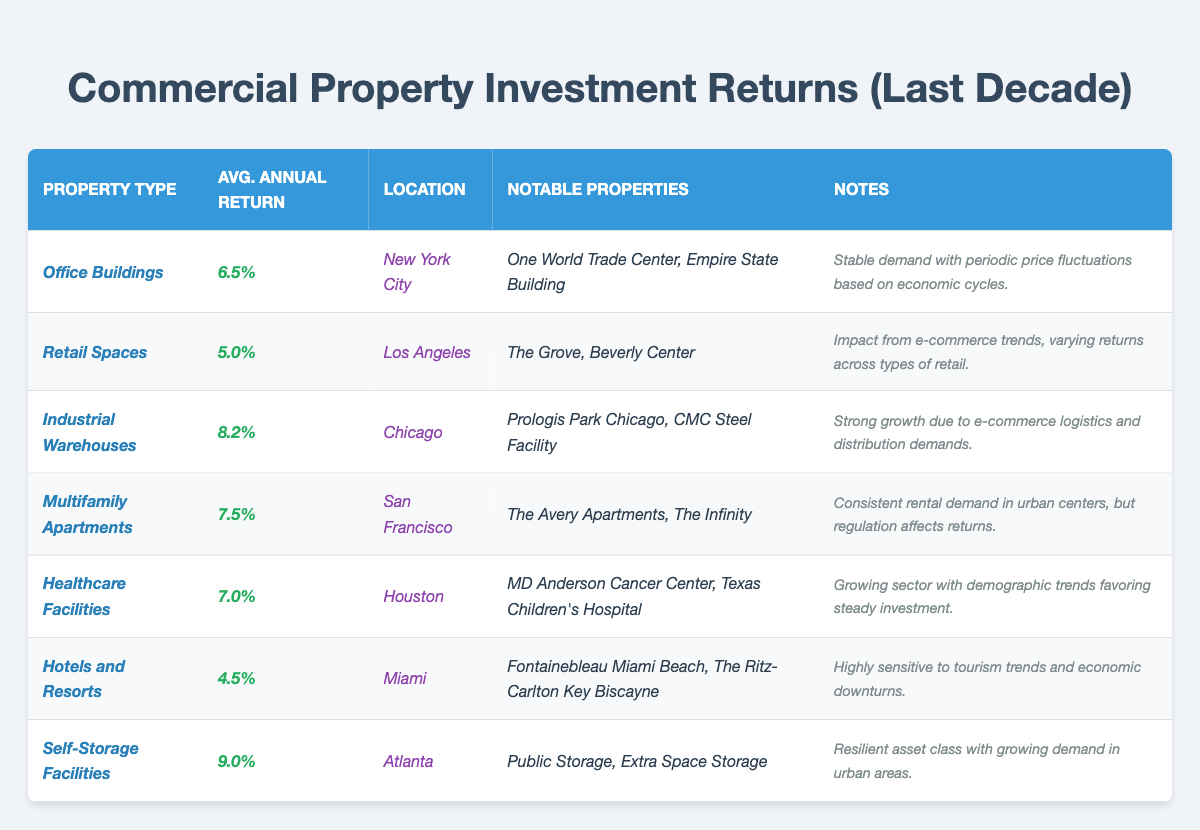What is the average annual return for Office Buildings? The table shows that the average annual return for Office Buildings is explicitly listed as 6.5%.
Answer: 6.5% Which property type has the highest average annual return? By inspecting the table, the highest average annual return is listed for Self-Storage Facilities at 9.0%.
Answer: Self-Storage Facilities Is the average annual return for Healthcare Facilities higher than that for Hotels and Resorts? The average annual return for Healthcare Facilities is 7.0%, and for Hotels and Resorts, it is 4.5%. Since 7.0% is greater than 4.5%, the statement is true.
Answer: Yes What are the notable properties for Multifamily Apartments? The notable properties for Multifamily Apartments are listed in the table as The Avery Apartments and The Infinity.
Answer: The Avery Apartments, The Infinity How does the average annual return for Retail Spaces compare to that of Industrial Warehouses? The average annual return for Retail Spaces is 5.0%, while for Industrial Warehouses, it is 8.2%. Since 5.0% is less than 8.2%, Retail Spaces have a lower return than Industrial Warehouses.
Answer: Lower What is the difference in average annual return between Industrial Warehouses and Self-Storage Facilities? The average annual return for Industrial Warehouses is 8.2% and for Self-Storage Facilities is 9.0%. To find the difference, subtract: 9.0% - 8.2% = 0.8%.
Answer: 0.8% Are all property types listed in the table located in different cities? Each property type in the table specifies a unique city for its location, which confirms that they are all different.
Answer: Yes What is the average annual return for all property types combined? First, sum the average annual returns: 6.5% + 5.0% + 8.2% + 7.5% + 7.0% + 4.5% + 9.0% = 47.7%. Then, divide by the number of property types (7) to get the average: 47.7% / 7 = 6.81%.
Answer: 6.81% Which property type has the lowest return, and what percentage is it? The table shows that the Hotels and Resorts has the lowest average annual return at 4.5%.
Answer: Hotels and Resorts, 4.5% Is there a property type with an average return above 8%? The table indicates that Industrial Warehouses (8.2%) and Self-Storage Facilities (9.0%) both have average returns above 8%.
Answer: Yes What unique factors affect the returns of Retail Spaces? The notes section for Retail Spaces mentions that e-commerce trends impact the returns, which indicates the influence of online shopping on this property type.
Answer: E-commerce trends 